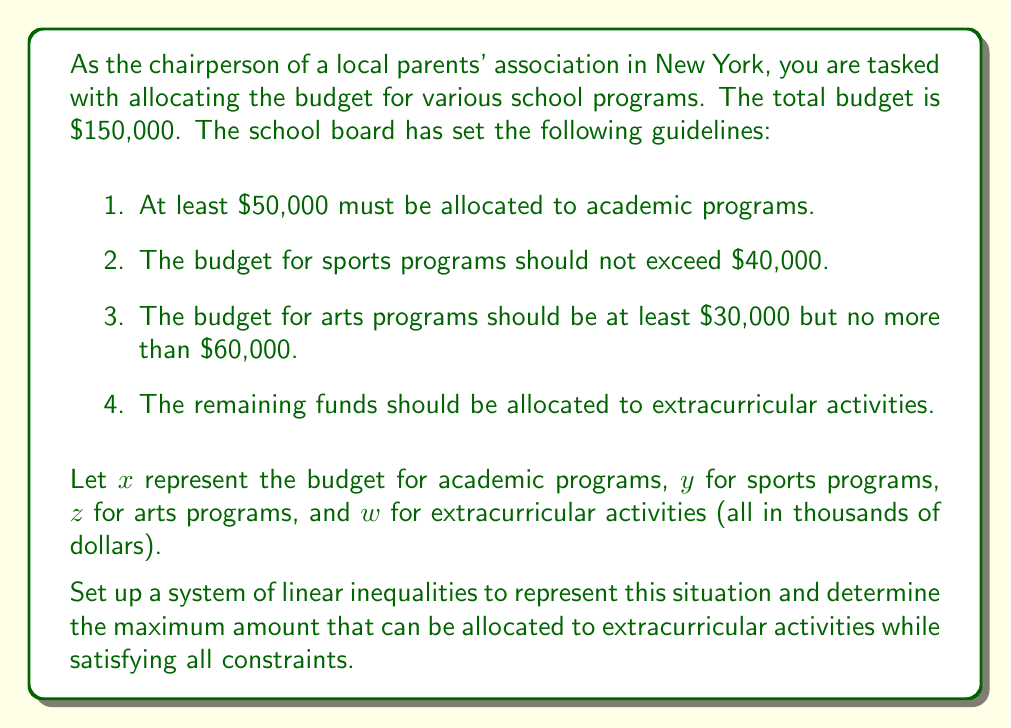What is the answer to this math problem? Let's approach this step-by-step:

1. First, we need to set up the linear inequalities based on the given constraints:

   a. For academic programs: $x \geq 50$
   b. For sports programs: $y \leq 40$
   c. For arts programs: $30 \leq z \leq 60$
   d. Total budget constraint: $x + y + z + w = 150$

2. We want to maximize $w$, the budget for extracurricular activities.

3. To find the maximum value of $w$, we need to minimize the sum of $x$, $y$, and $z$ while satisfying all constraints:

   - Minimum value for $x$: 50
   - Minimum value for $y$: 0 (since $y \leq 40$, the minimum could be 0)
   - Minimum value for $z$: 30

4. Therefore, the maximum value for $w$ can be calculated as:

   $w_{max} = 150 - (x_{min} + y_{min} + z_{min})$
   $w_{max} = 150 - (50 + 0 + 30)$
   $w_{max} = 150 - 80 = 70$

5. We can verify that this solution satisfies all constraints:
   
   $50 + 0 + 30 + 70 = 150$

   Academic programs ($x$) receive the minimum required amount.
   Sports programs ($y$) receive no funding, which is allowed as long as it doesn't exceed $40,000.
   Arts programs ($z$) receive the minimum required amount.
   Extracurricular activities ($w$) receive the remaining funds.

Thus, the maximum amount that can be allocated to extracurricular activities is $70,000 while satisfying all constraints.
Answer: The maximum amount that can be allocated to extracurricular activities while satisfying all constraints is $70,000. 